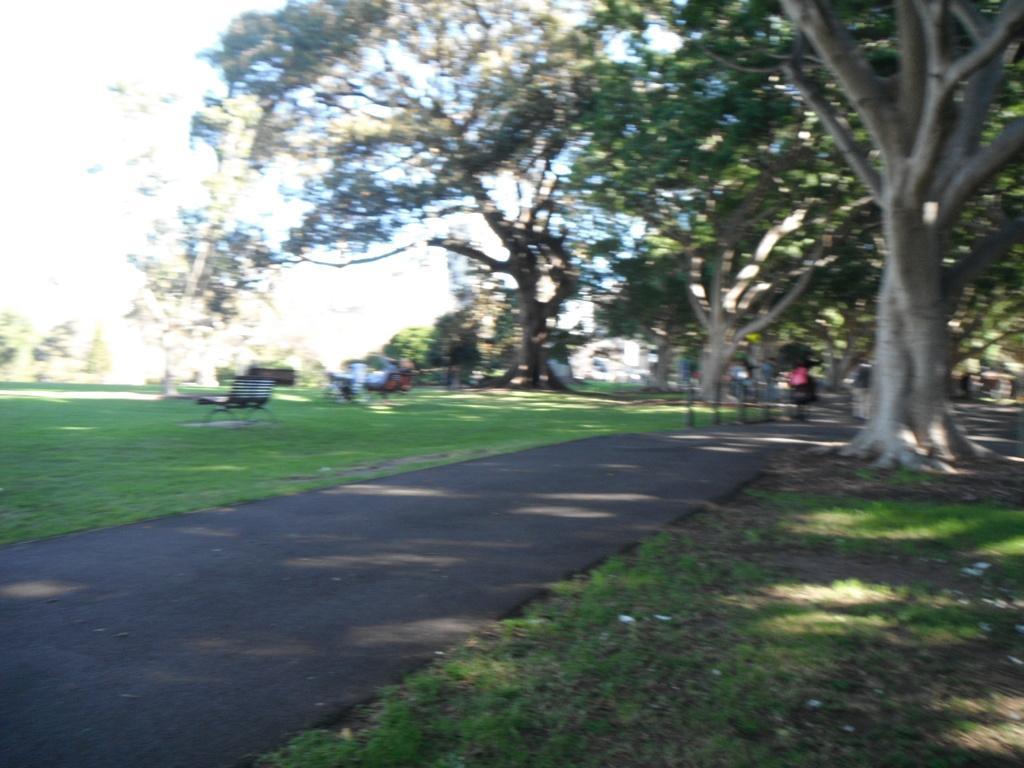How would you summarize this image in a sentence or two? In this picture we can see grass at the bottom, there are some trees here, we can see a bench here, there is the sky at the left top of the picture. 